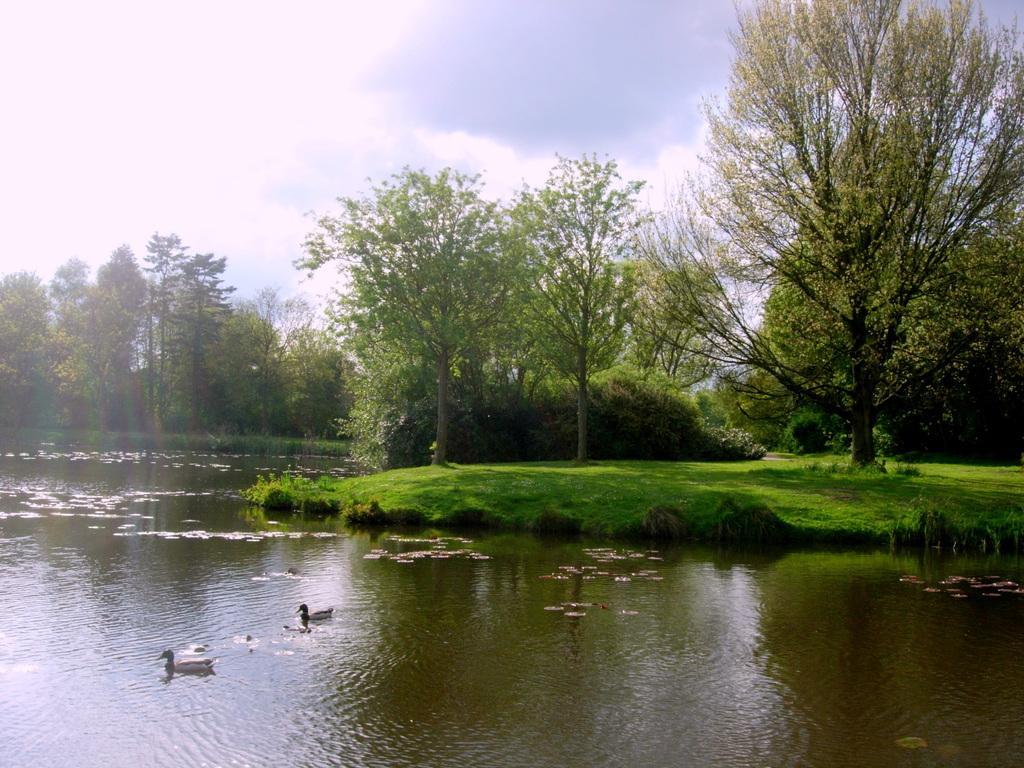Can you describe this image briefly? In this image we can see some birds and leaves in a water body. We can also see some grass, plants, a group of trees and the sky which looks cloudy. 